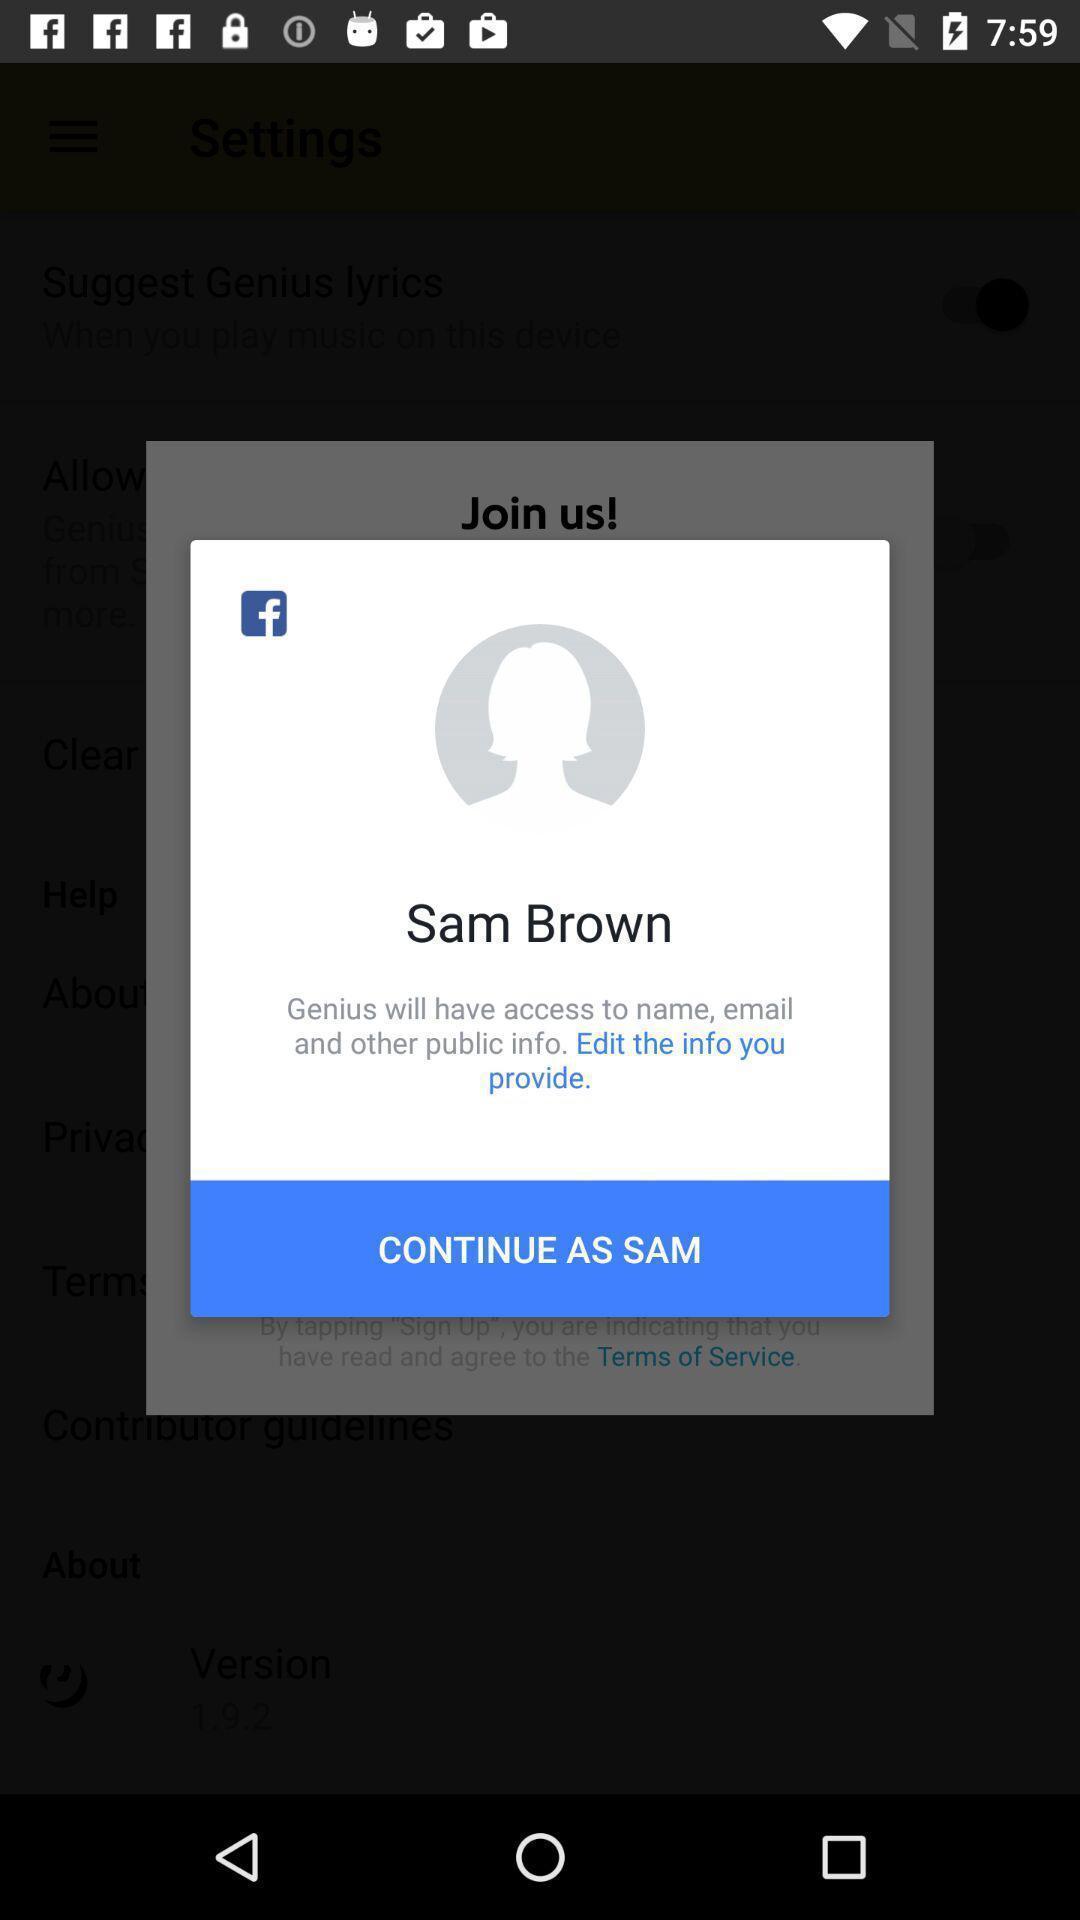Describe the visual elements of this screenshot. Popup showing information about profile and continue option. 